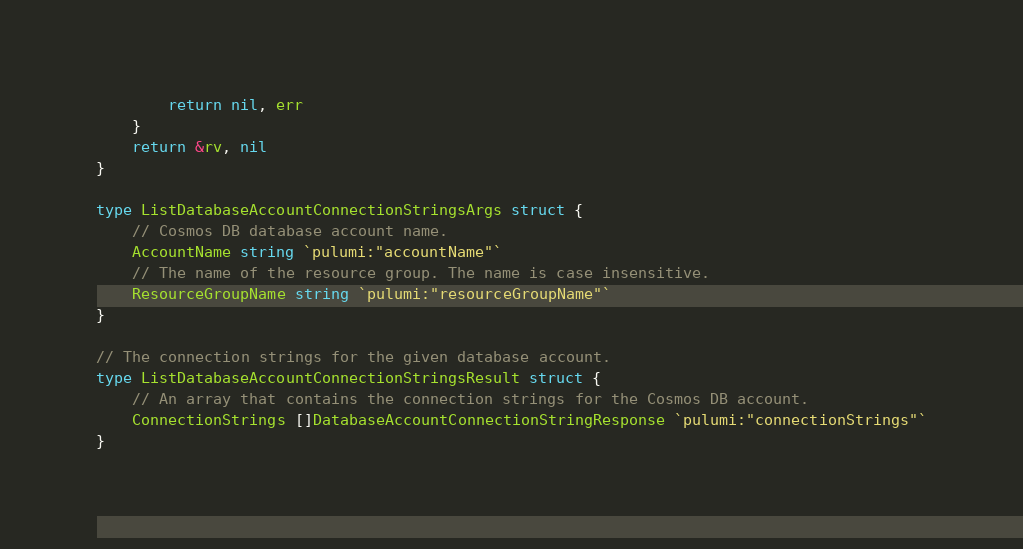Convert code to text. <code><loc_0><loc_0><loc_500><loc_500><_Go_>		return nil, err
	}
	return &rv, nil
}

type ListDatabaseAccountConnectionStringsArgs struct {
	// Cosmos DB database account name.
	AccountName string `pulumi:"accountName"`
	// The name of the resource group. The name is case insensitive.
	ResourceGroupName string `pulumi:"resourceGroupName"`
}

// The connection strings for the given database account.
type ListDatabaseAccountConnectionStringsResult struct {
	// An array that contains the connection strings for the Cosmos DB account.
	ConnectionStrings []DatabaseAccountConnectionStringResponse `pulumi:"connectionStrings"`
}
</code> 